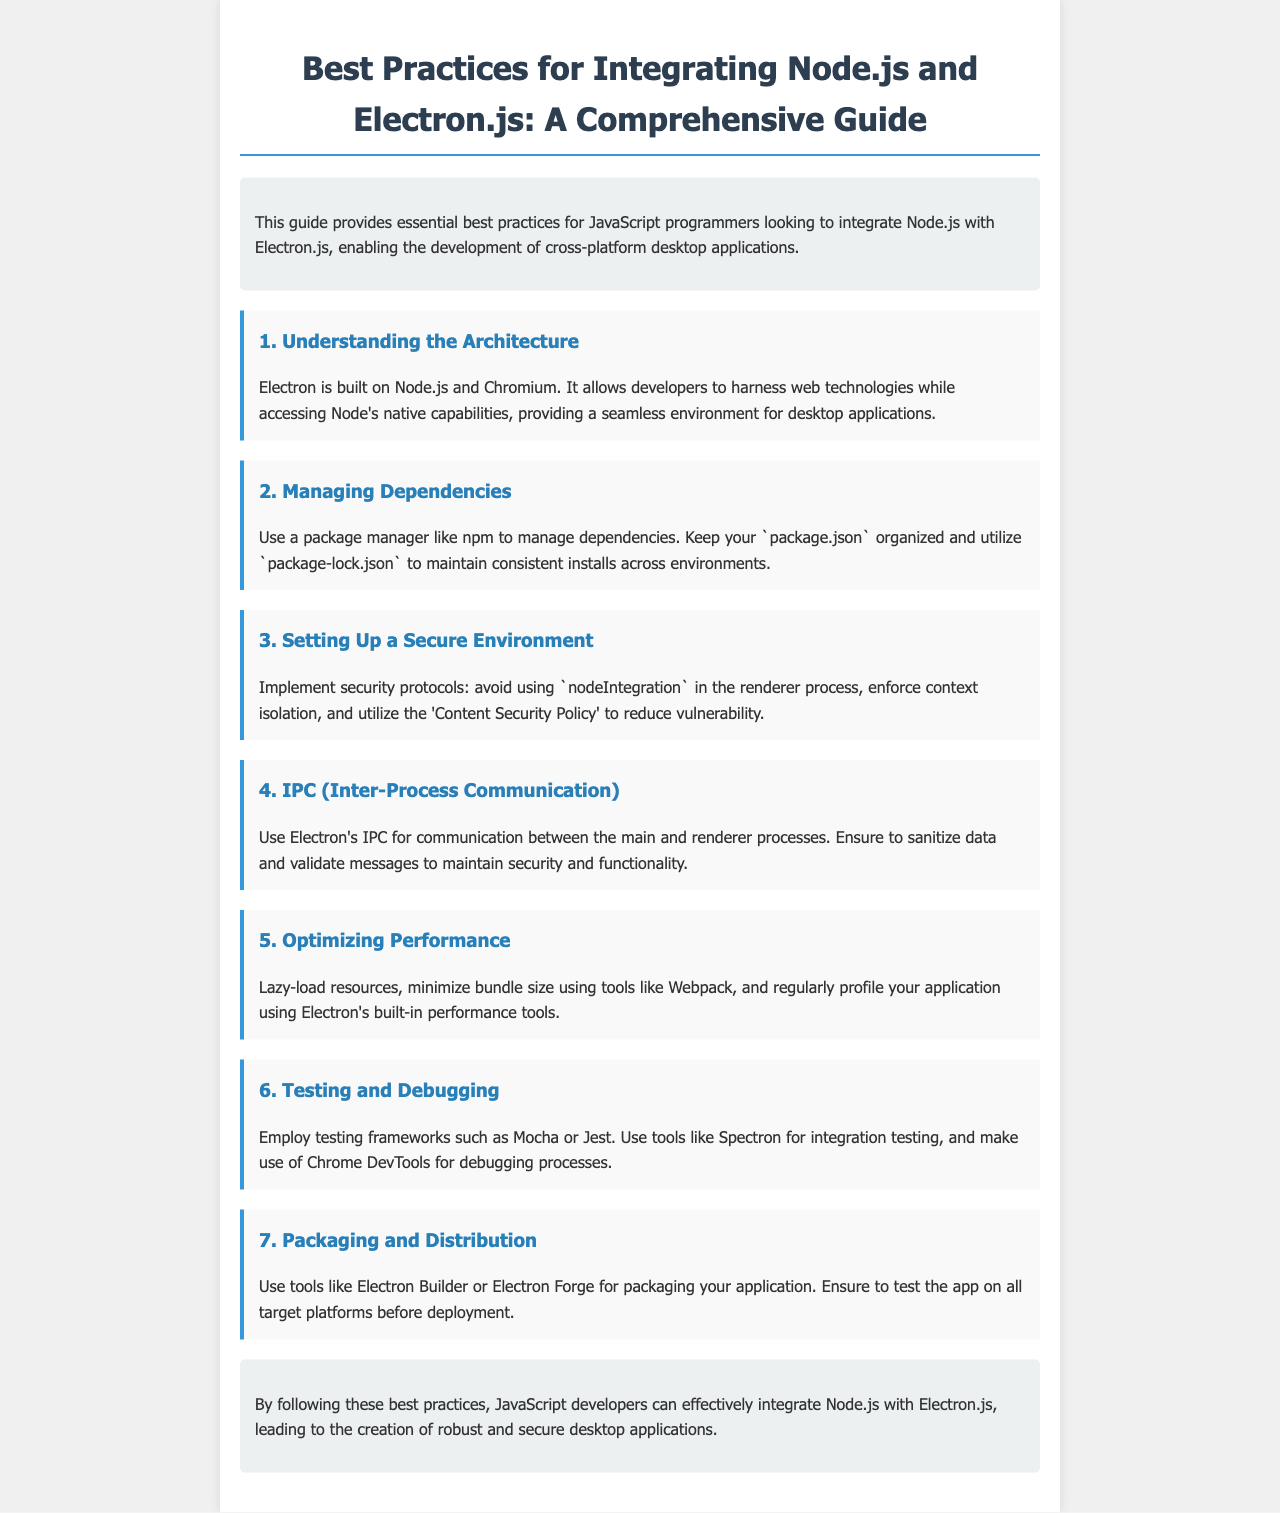What is the primary focus of this guide? The guide aims to provide best practices for integrating Node.js with Electron.js, particularly for JavaScript programmers.
Answer: best practices for integrating Node.js with Electron.js What are the main technologies behind Electron? Electron is built on Node.js and Chromium, which allows for the use of web technologies alongside Node's capabilities.
Answer: Node.js and Chromium Which package manager is recommended for managing dependencies? The document recommends using npm to manage dependencies in Electron applications.
Answer: npm What security protocol is suggested to avoid in the renderer process? The guide advises against using nodeIntegration in the renderer process to enhance security.
Answer: nodeIntegration What testing frameworks are mentioned in the document? The document mentions testing frameworks such as Mocha and Jest for testing Electron applications.
Answer: Mocha and Jest What tool can be used for packaging the Electron application? The document suggests using Electron Builder or Electron Forge for packaging applications built with Electron.
Answer: Electron Builder or Electron Forge What is recommended for optimizing performance? The document suggests lazy-loading resources and minimizing bundle size to optimize performance in Electron applications.
Answer: lazy-load resources, minimize bundle size How should data be handled during IPC? It is recommended to sanitize data and validate messages for secure IPC communication between processes.
Answer: sanitize data and validate messages What is the conclusion of the guide? The conclusion emphasizes the importance of following best practices for creating robust and secure desktop applications with Node.js and Electron.js.
Answer: robust and secure desktop applications 